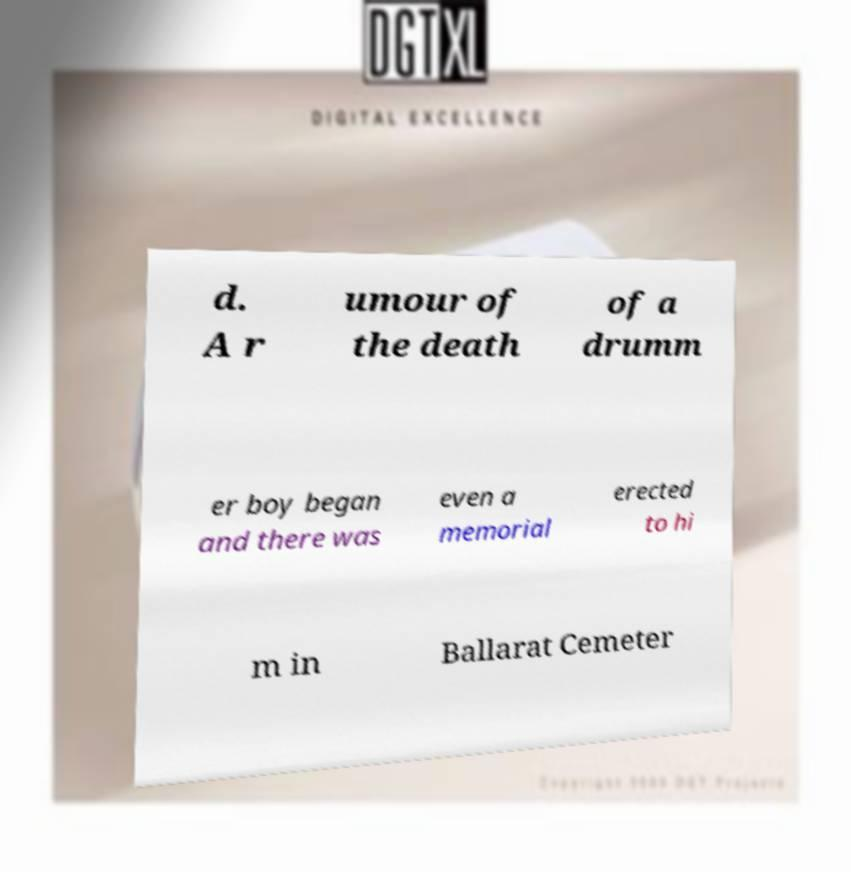Could you assist in decoding the text presented in this image and type it out clearly? d. A r umour of the death of a drumm er boy began and there was even a memorial erected to hi m in Ballarat Cemeter 